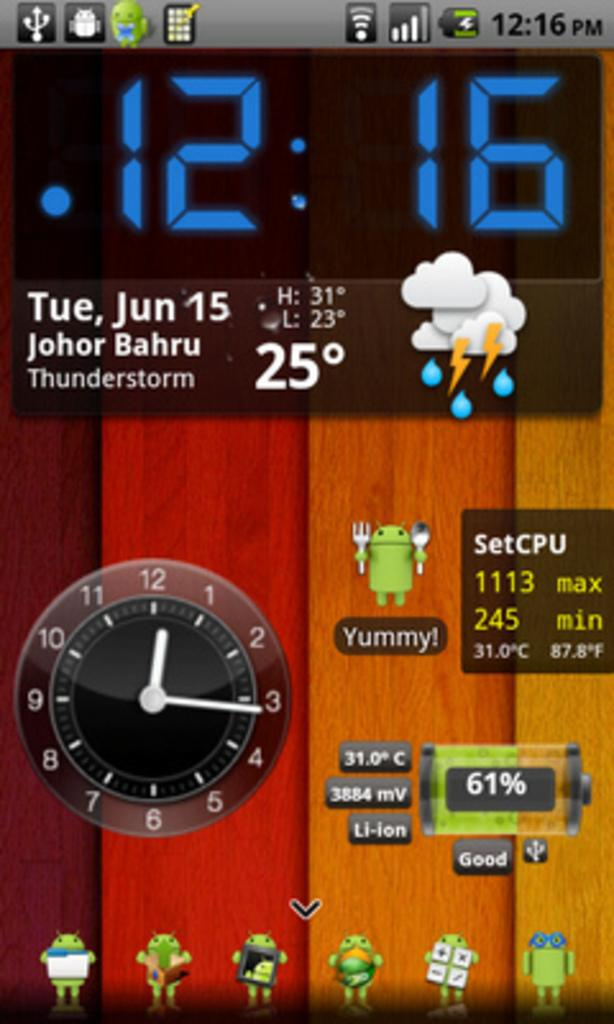Provide a one-sentence caption for the provided image. A device screen shows several different apps, and that the date is June 15. 